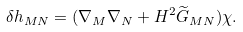Convert formula to latex. <formula><loc_0><loc_0><loc_500><loc_500>\delta h _ { M N } = ( \nabla _ { M } \nabla _ { N } + H ^ { 2 } { \widetilde { G } } _ { M N } ) \chi .</formula> 